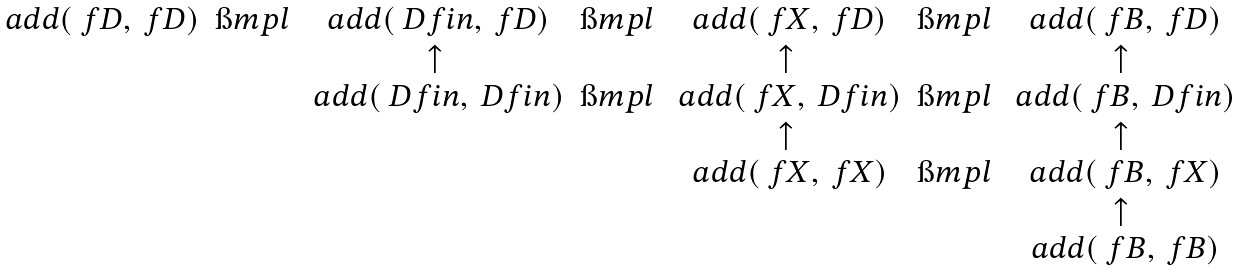<formula> <loc_0><loc_0><loc_500><loc_500>\begin{matrix} \ a d d ( \ f D , \ f D ) & \i m p l & \ a d d ( \ D f i n , \ f D ) & \i m p l & \ a d d ( \ f X , \ f D ) & \i m p l & \ a d d ( \ f B , \ f D ) \\ & & \uparrow & & \uparrow & & \uparrow \\ & & \ a d d ( \ D f i n , \ D f i n ) & \i m p l & \ a d d ( \ f X , \ D f i n ) & \i m p l & \ a d d ( \ f B , \ D f i n ) \\ & & & & \uparrow & & \uparrow \\ & & & & \ a d d ( \ f X , \ f X ) & \i m p l & \ a d d ( \ f B , \ f X ) \\ & & & & & & \uparrow \\ & & & & & & \ a d d ( \ f B , \ f B ) \end{matrix}</formula> 